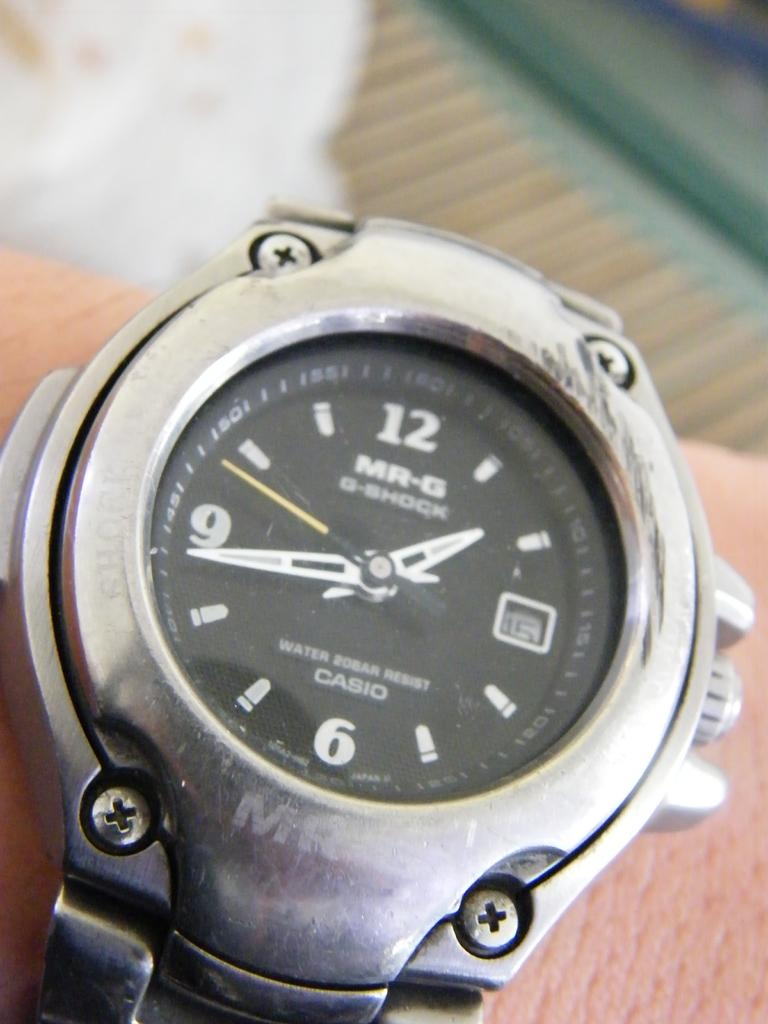<image>
Offer a succinct explanation of the picture presented. A silver watch says "MR-G" on the face. 